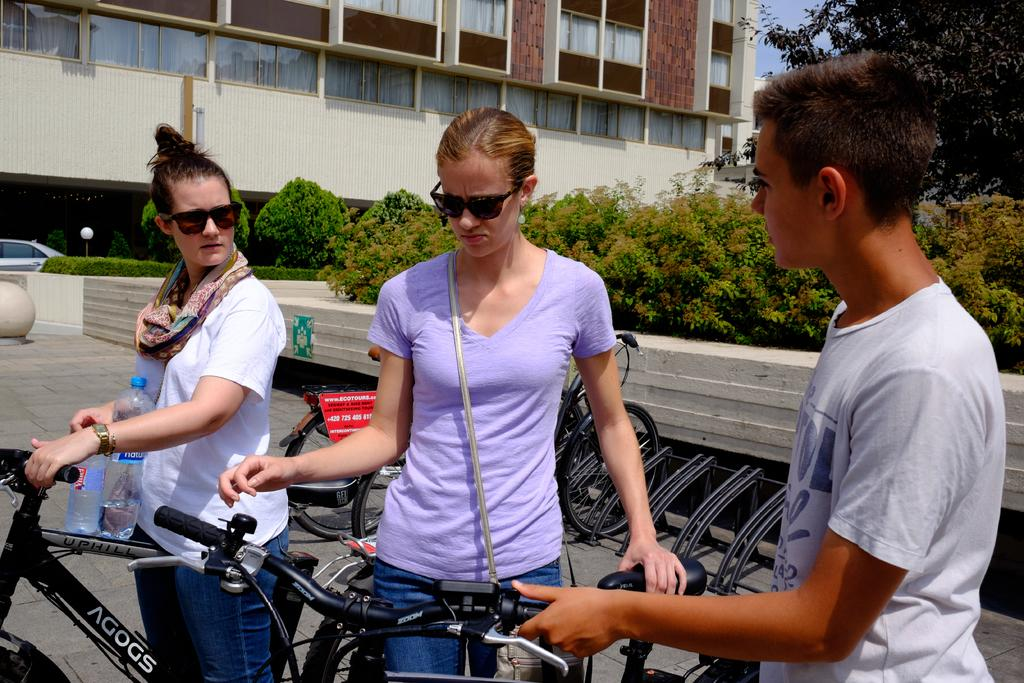What type of structure is visible in the image? There is a building in the image. What natural elements can be seen in the image? There are trees in the image. How many people are present in the image? There are three people standing in the image. What mode of transportation can be seen in the image? There are bicycles and a car in the image. What type of food is being traded between the people in the image? There is no indication of food or trading in the image; it only shows a building, trees, three people, bicycles, and a car. 